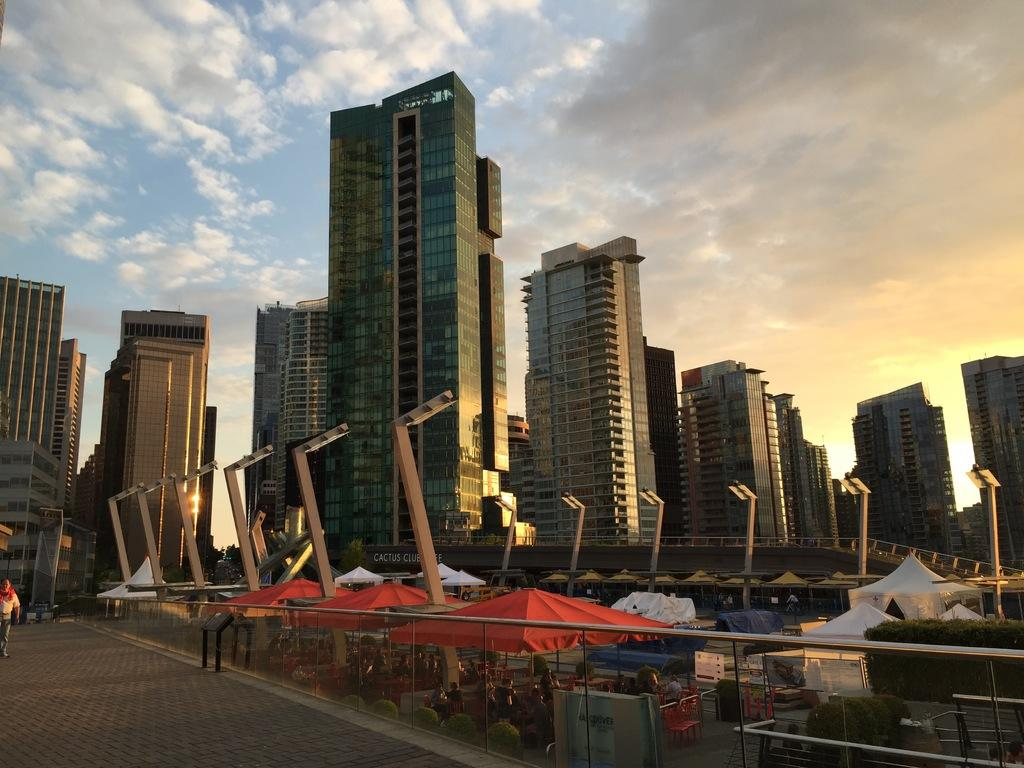What can be seen running through the image? There is a path in the image. What type of temporary shelters are visible in the image? There are tents in the image. What are the poles with lights used for in the image? The poles with lights are used for illumination in the image. What type of structures can be seen in the background of the image? There are tower buildings in the background of the image. What is visible in the sky in the image? The sky is visible in the background of the image, and clouds are present. How many fifths are present in the image? There is no mention of a "fifth" in the image, so it cannot be determined how many there are. What type of fowl can be seen flying in the image? There are no birds or fowl visible in the image. 